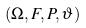<formula> <loc_0><loc_0><loc_500><loc_500>( \Omega , F , P , \vartheta )</formula> 